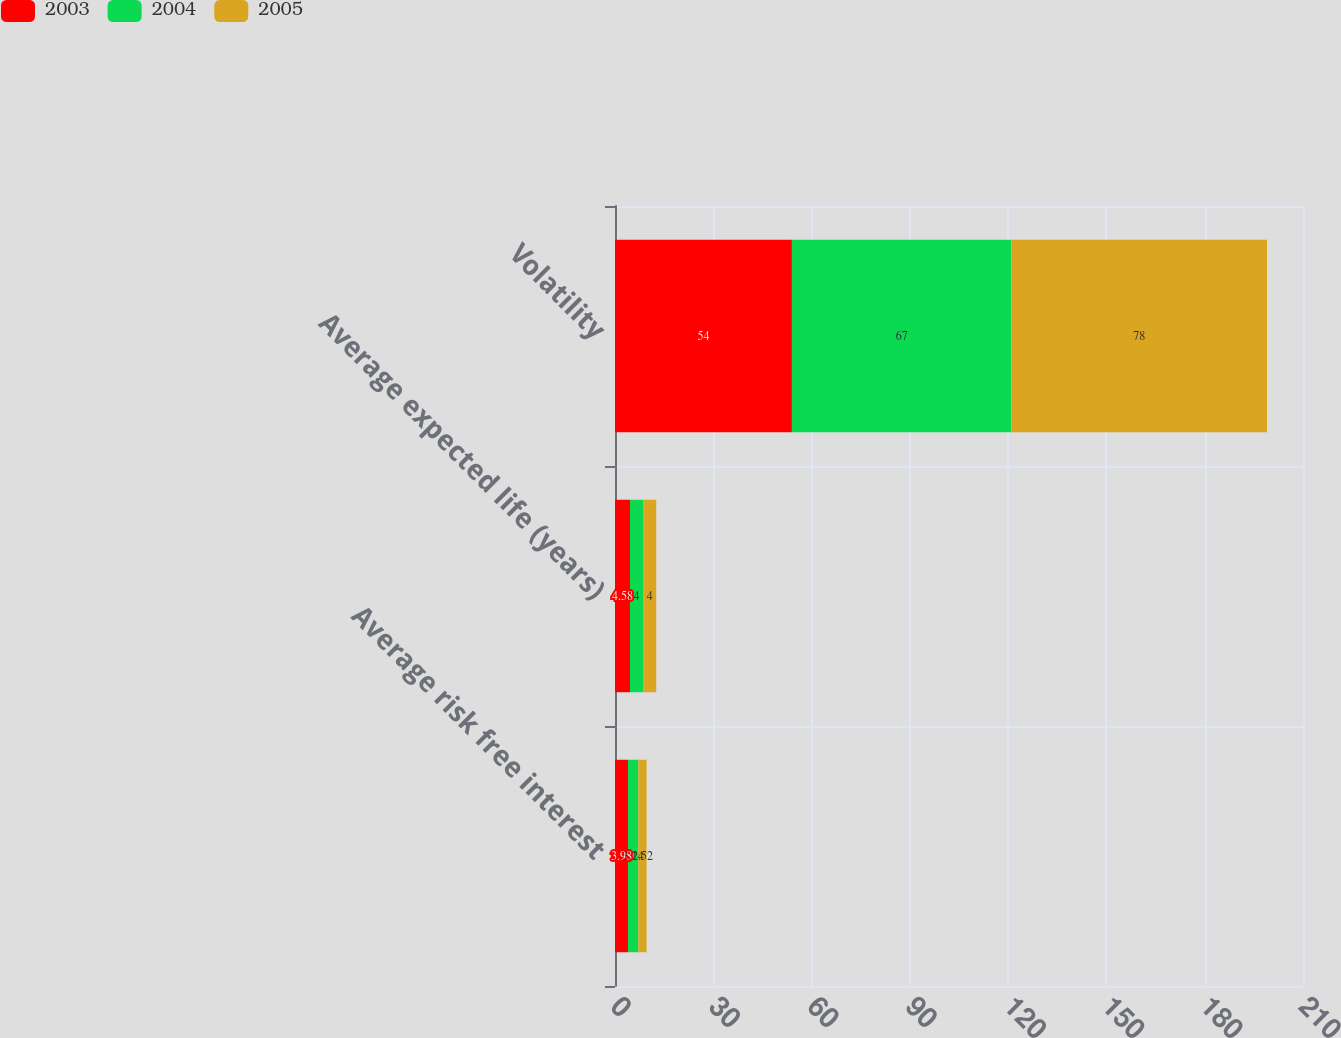<chart> <loc_0><loc_0><loc_500><loc_500><stacked_bar_chart><ecel><fcel>Average risk free interest<fcel>Average expected life (years)<fcel>Volatility<nl><fcel>2003<fcel>3.98<fcel>4.58<fcel>54<nl><fcel>2004<fcel>3.14<fcel>4<fcel>67<nl><fcel>2005<fcel>2.52<fcel>4<fcel>78<nl></chart> 